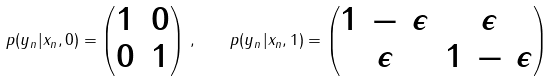Convert formula to latex. <formula><loc_0><loc_0><loc_500><loc_500>p ( y _ { n } | x _ { n } , 0 ) = \begin{pmatrix} 1 & 0 \\ 0 & 1 \end{pmatrix} \, , \quad p ( y _ { n } | x _ { n } , 1 ) = \begin{pmatrix} 1 \, - \, \epsilon & \epsilon \\ \epsilon & 1 \, - \, \epsilon \end{pmatrix}</formula> 